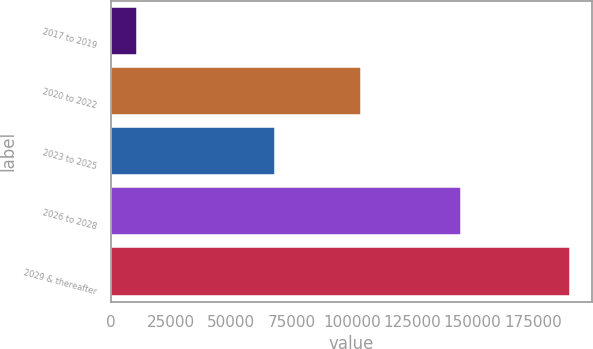Convert chart to OTSL. <chart><loc_0><loc_0><loc_500><loc_500><bar_chart><fcel>2017 to 2019<fcel>2020 to 2022<fcel>2023 to 2025<fcel>2026 to 2028<fcel>2029 & thereafter<nl><fcel>10950<fcel>103886<fcel>67905<fcel>145043<fcel>190204<nl></chart> 